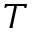<formula> <loc_0><loc_0><loc_500><loc_500>T</formula> 